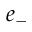Convert formula to latex. <formula><loc_0><loc_0><loc_500><loc_500>e _ { - }</formula> 